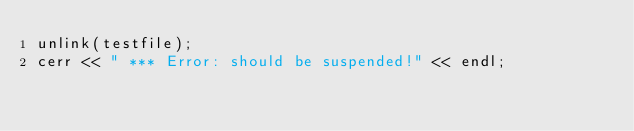<code> <loc_0><loc_0><loc_500><loc_500><_ObjectiveC_>unlink(testfile);
cerr << " *** Error: should be suspended!" << endl;
</code> 